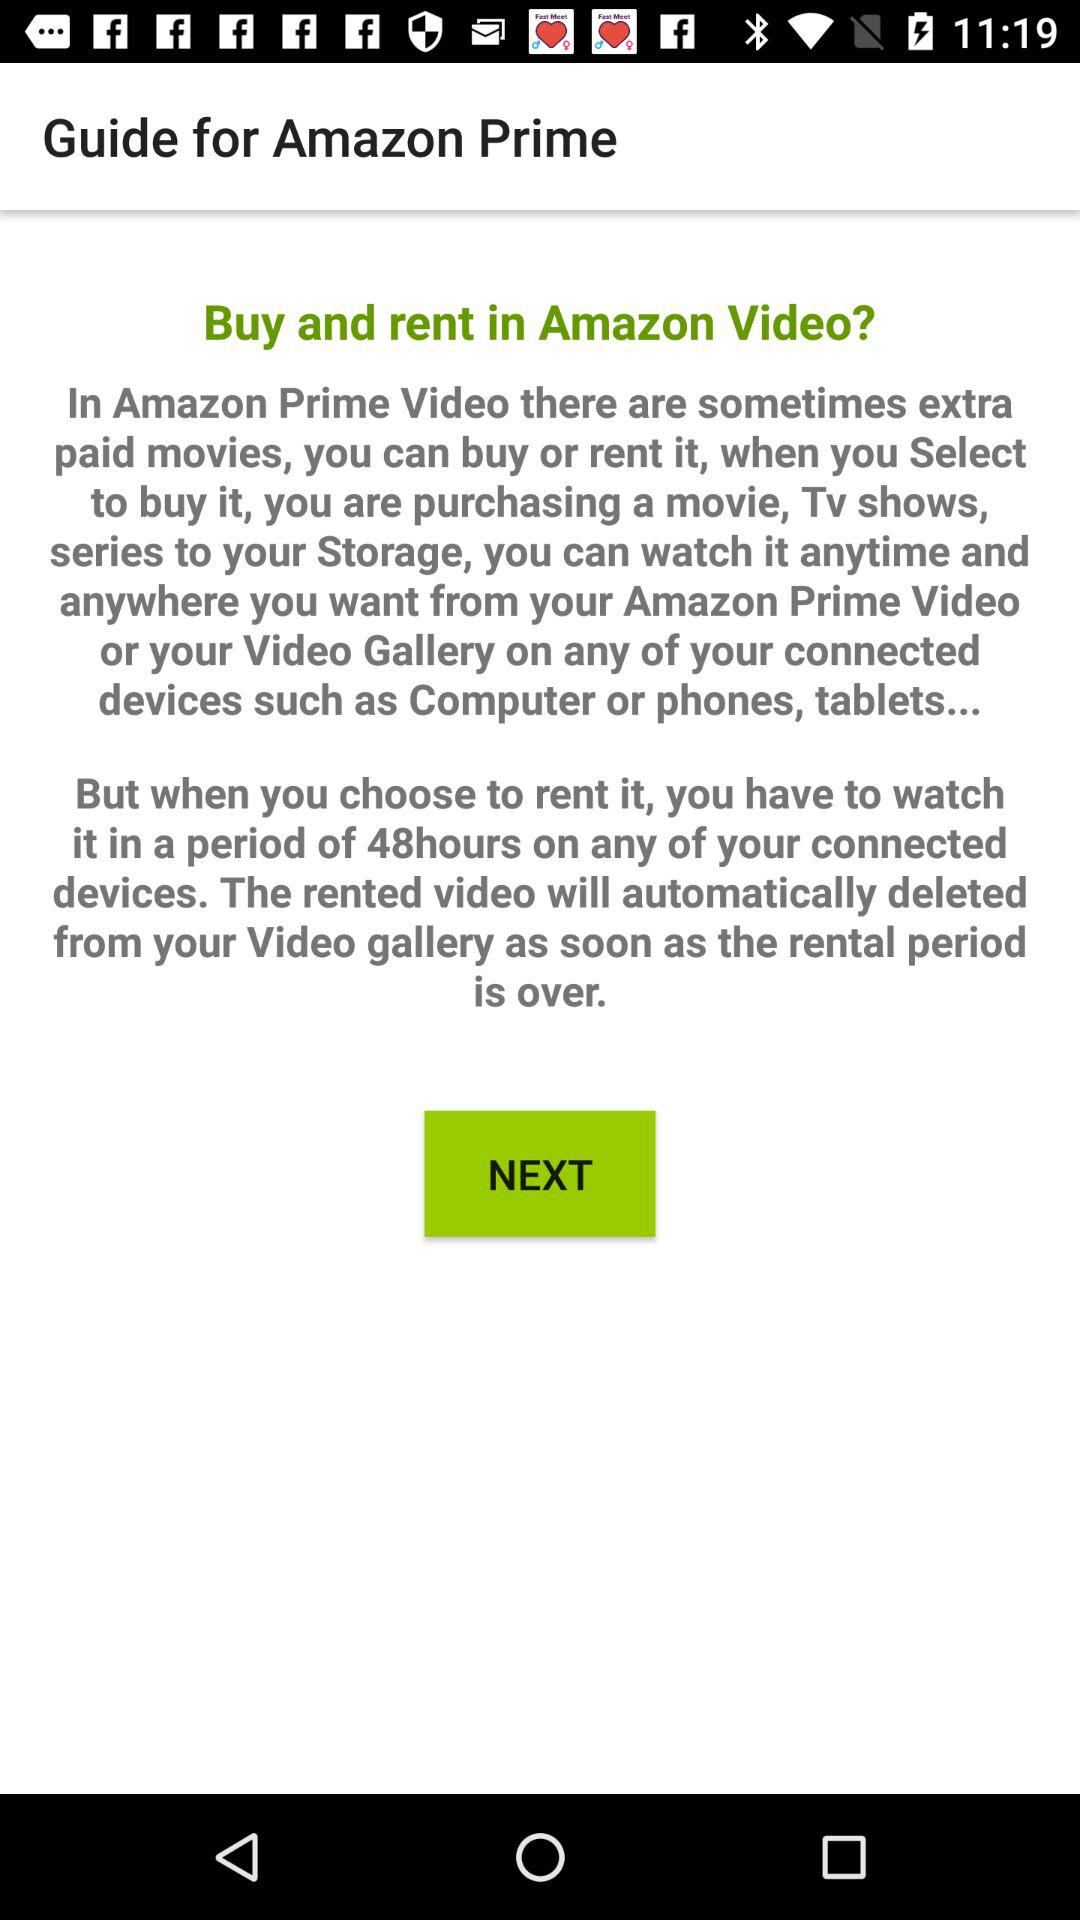How long do you have to watch a rented movie before it is deleted?
Answer the question using a single word or phrase. 48 hours 